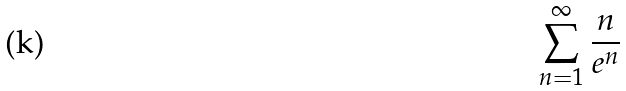Convert formula to latex. <formula><loc_0><loc_0><loc_500><loc_500>\sum _ { n = 1 } ^ { \infty } \frac { n } { e ^ { n } }</formula> 